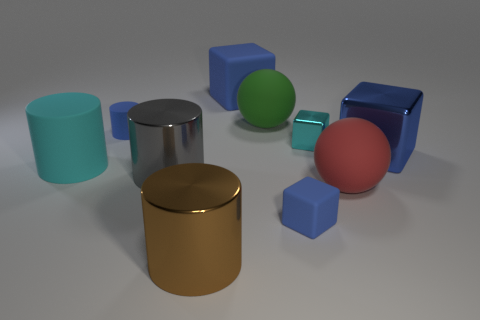What material is the large gray cylinder? metal 